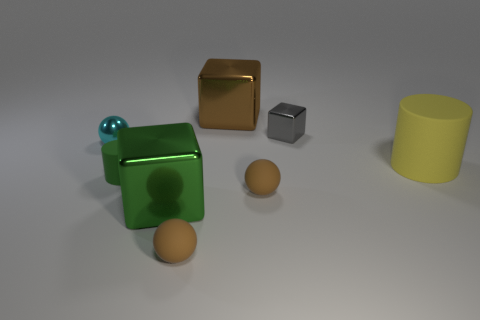Add 1 brown objects. How many objects exist? 9 Subtract all small brown balls. How many balls are left? 1 Subtract 3 cubes. How many cubes are left? 0 Subtract all red spheres. How many gray blocks are left? 1 Subtract all green cylinders. How many cylinders are left? 1 Subtract 1 gray blocks. How many objects are left? 7 Subtract all balls. How many objects are left? 5 Subtract all brown cubes. Subtract all yellow cylinders. How many cubes are left? 2 Subtract all tiny cyan spheres. Subtract all large cylinders. How many objects are left? 6 Add 2 brown cubes. How many brown cubes are left? 3 